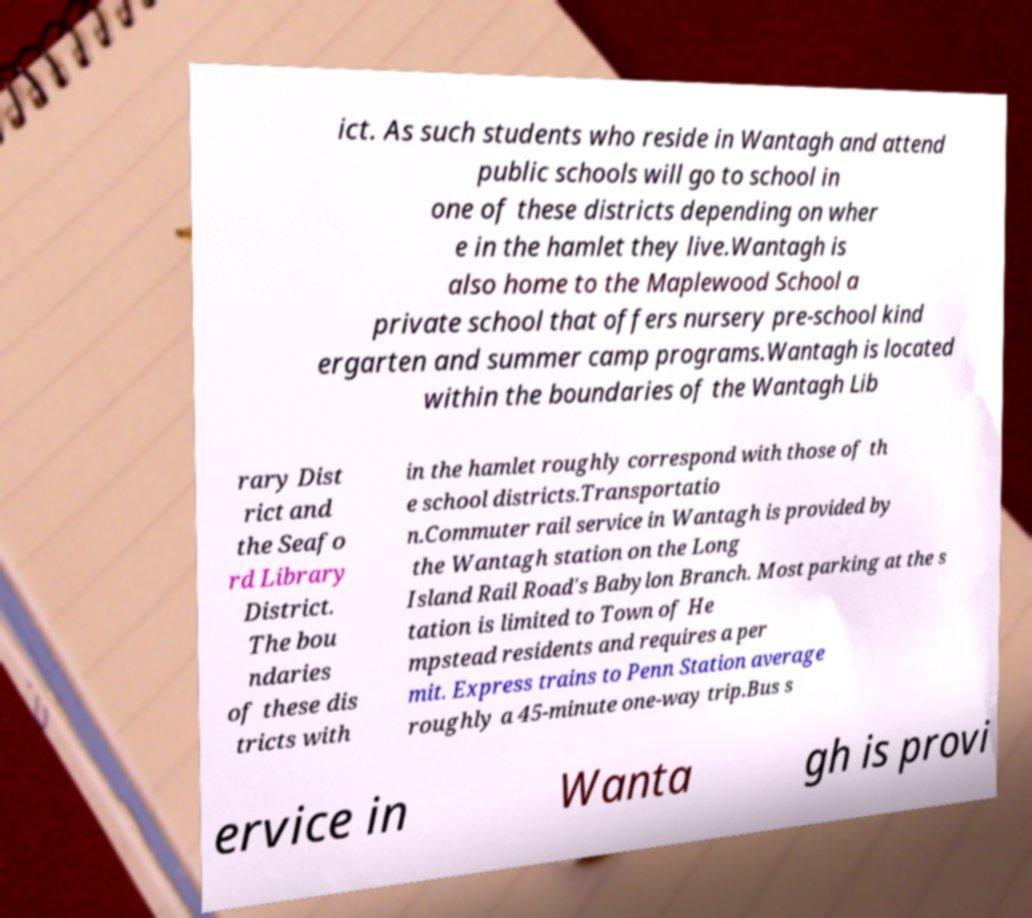I need the written content from this picture converted into text. Can you do that? ict. As such students who reside in Wantagh and attend public schools will go to school in one of these districts depending on wher e in the hamlet they live.Wantagh is also home to the Maplewood School a private school that offers nursery pre-school kind ergarten and summer camp programs.Wantagh is located within the boundaries of the Wantagh Lib rary Dist rict and the Seafo rd Library District. The bou ndaries of these dis tricts with in the hamlet roughly correspond with those of th e school districts.Transportatio n.Commuter rail service in Wantagh is provided by the Wantagh station on the Long Island Rail Road's Babylon Branch. Most parking at the s tation is limited to Town of He mpstead residents and requires a per mit. Express trains to Penn Station average roughly a 45-minute one-way trip.Bus s ervice in Wanta gh is provi 